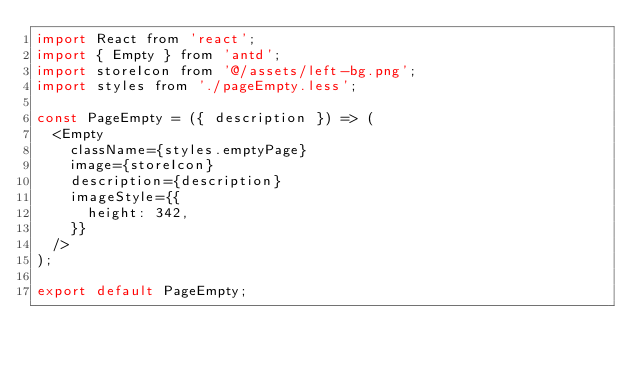Convert code to text. <code><loc_0><loc_0><loc_500><loc_500><_JavaScript_>import React from 'react';
import { Empty } from 'antd';
import storeIcon from '@/assets/left-bg.png';
import styles from './pageEmpty.less';

const PageEmpty = ({ description }) => (
	<Empty
		className={styles.emptyPage}
		image={storeIcon}
		description={description}
		imageStyle={{
			height: 342,
		}}
	/>
);

export default PageEmpty;
</code> 